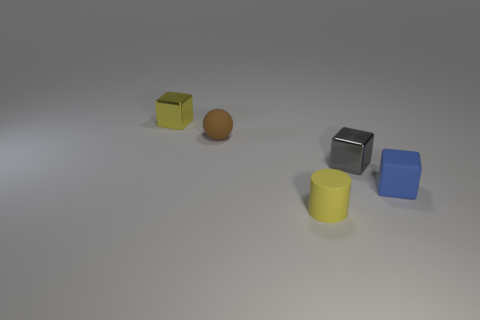What is the shape of the metallic thing right of the small yellow object that is to the left of the yellow rubber cylinder in front of the gray shiny cube?
Make the answer very short. Cube. There is a shiny thing behind the tiny brown rubber ball; is its shape the same as the rubber thing behind the blue object?
Provide a succinct answer. No. Is there anything else that has the same size as the brown object?
Your response must be concise. Yes. What number of cylinders are either small brown rubber things or tiny blue objects?
Offer a terse response. 0. Is the material of the yellow cube the same as the gray thing?
Provide a short and direct response. Yes. What number of other things are there of the same color as the ball?
Provide a succinct answer. 0. What is the shape of the metallic object on the left side of the gray cube?
Ensure brevity in your answer.  Cube. How many objects are either small blue cubes or small blocks?
Make the answer very short. 3. Is the size of the yellow matte cylinder the same as the rubber object behind the tiny blue rubber cube?
Offer a terse response. Yes. How many other objects are the same material as the cylinder?
Your answer should be compact. 2. 